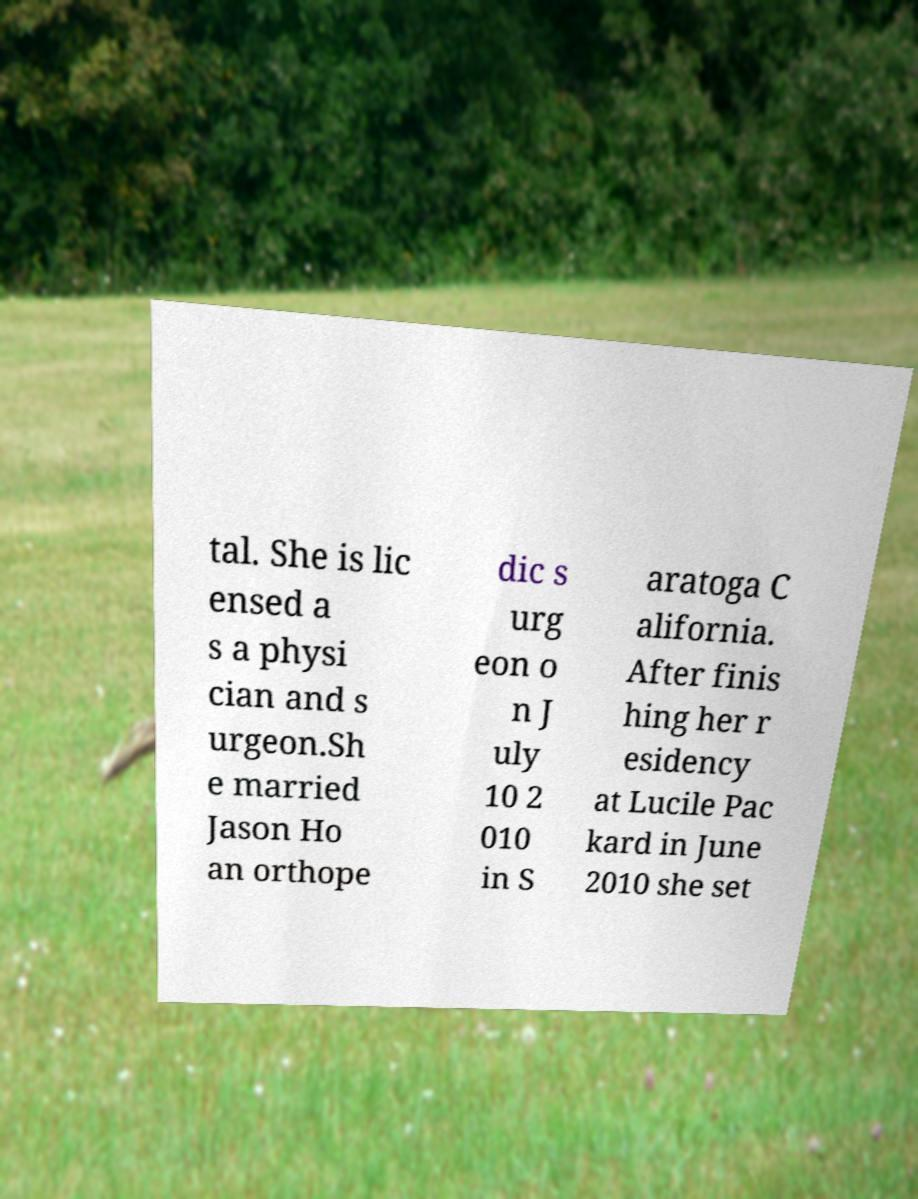Can you read and provide the text displayed in the image?This photo seems to have some interesting text. Can you extract and type it out for me? tal. She is lic ensed a s a physi cian and s urgeon.Sh e married Jason Ho an orthope dic s urg eon o n J uly 10 2 010 in S aratoga C alifornia. After finis hing her r esidency at Lucile Pac kard in June 2010 she set 